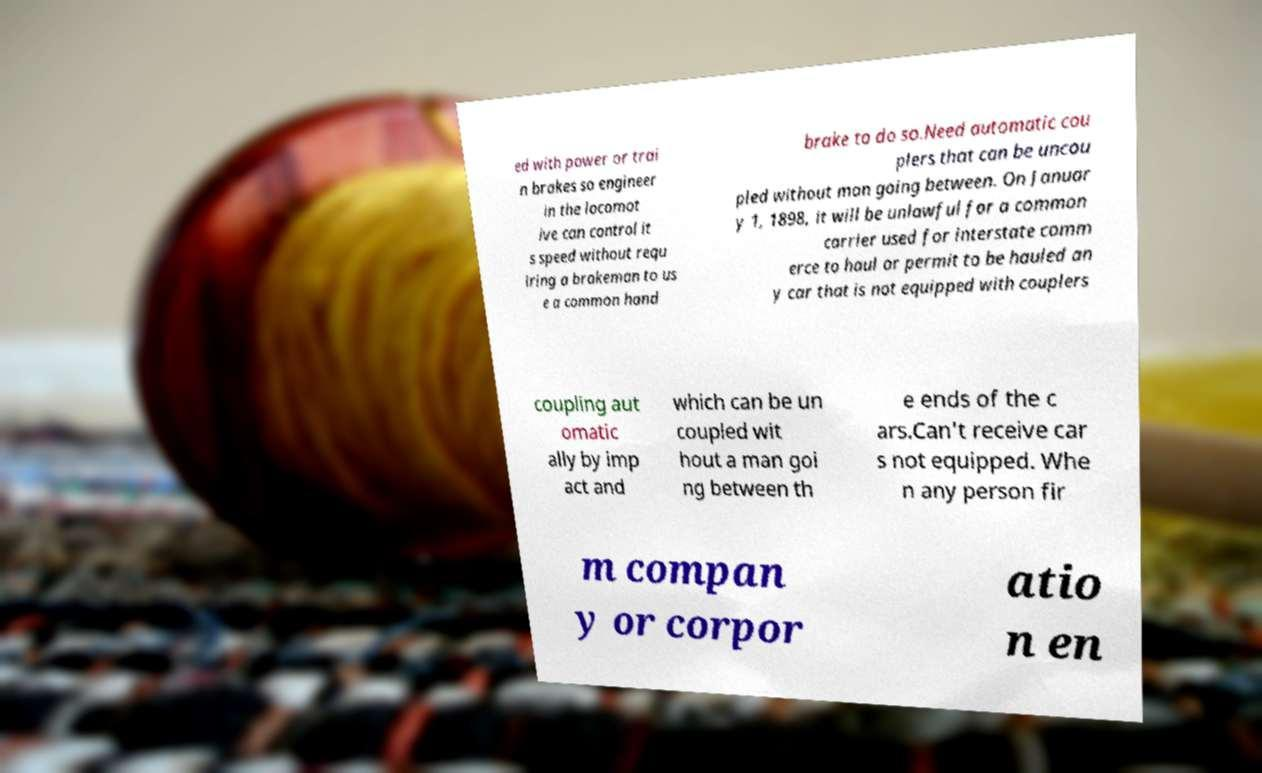I need the written content from this picture converted into text. Can you do that? ed with power or trai n brakes so engineer in the locomot ive can control it s speed without requ iring a brakeman to us e a common hand brake to do so.Need automatic cou plers that can be uncou pled without man going between. On Januar y 1, 1898, it will be unlawful for a common carrier used for interstate comm erce to haul or permit to be hauled an y car that is not equipped with couplers coupling aut omatic ally by imp act and which can be un coupled wit hout a man goi ng between th e ends of the c ars.Can't receive car s not equipped. Whe n any person fir m compan y or corpor atio n en 